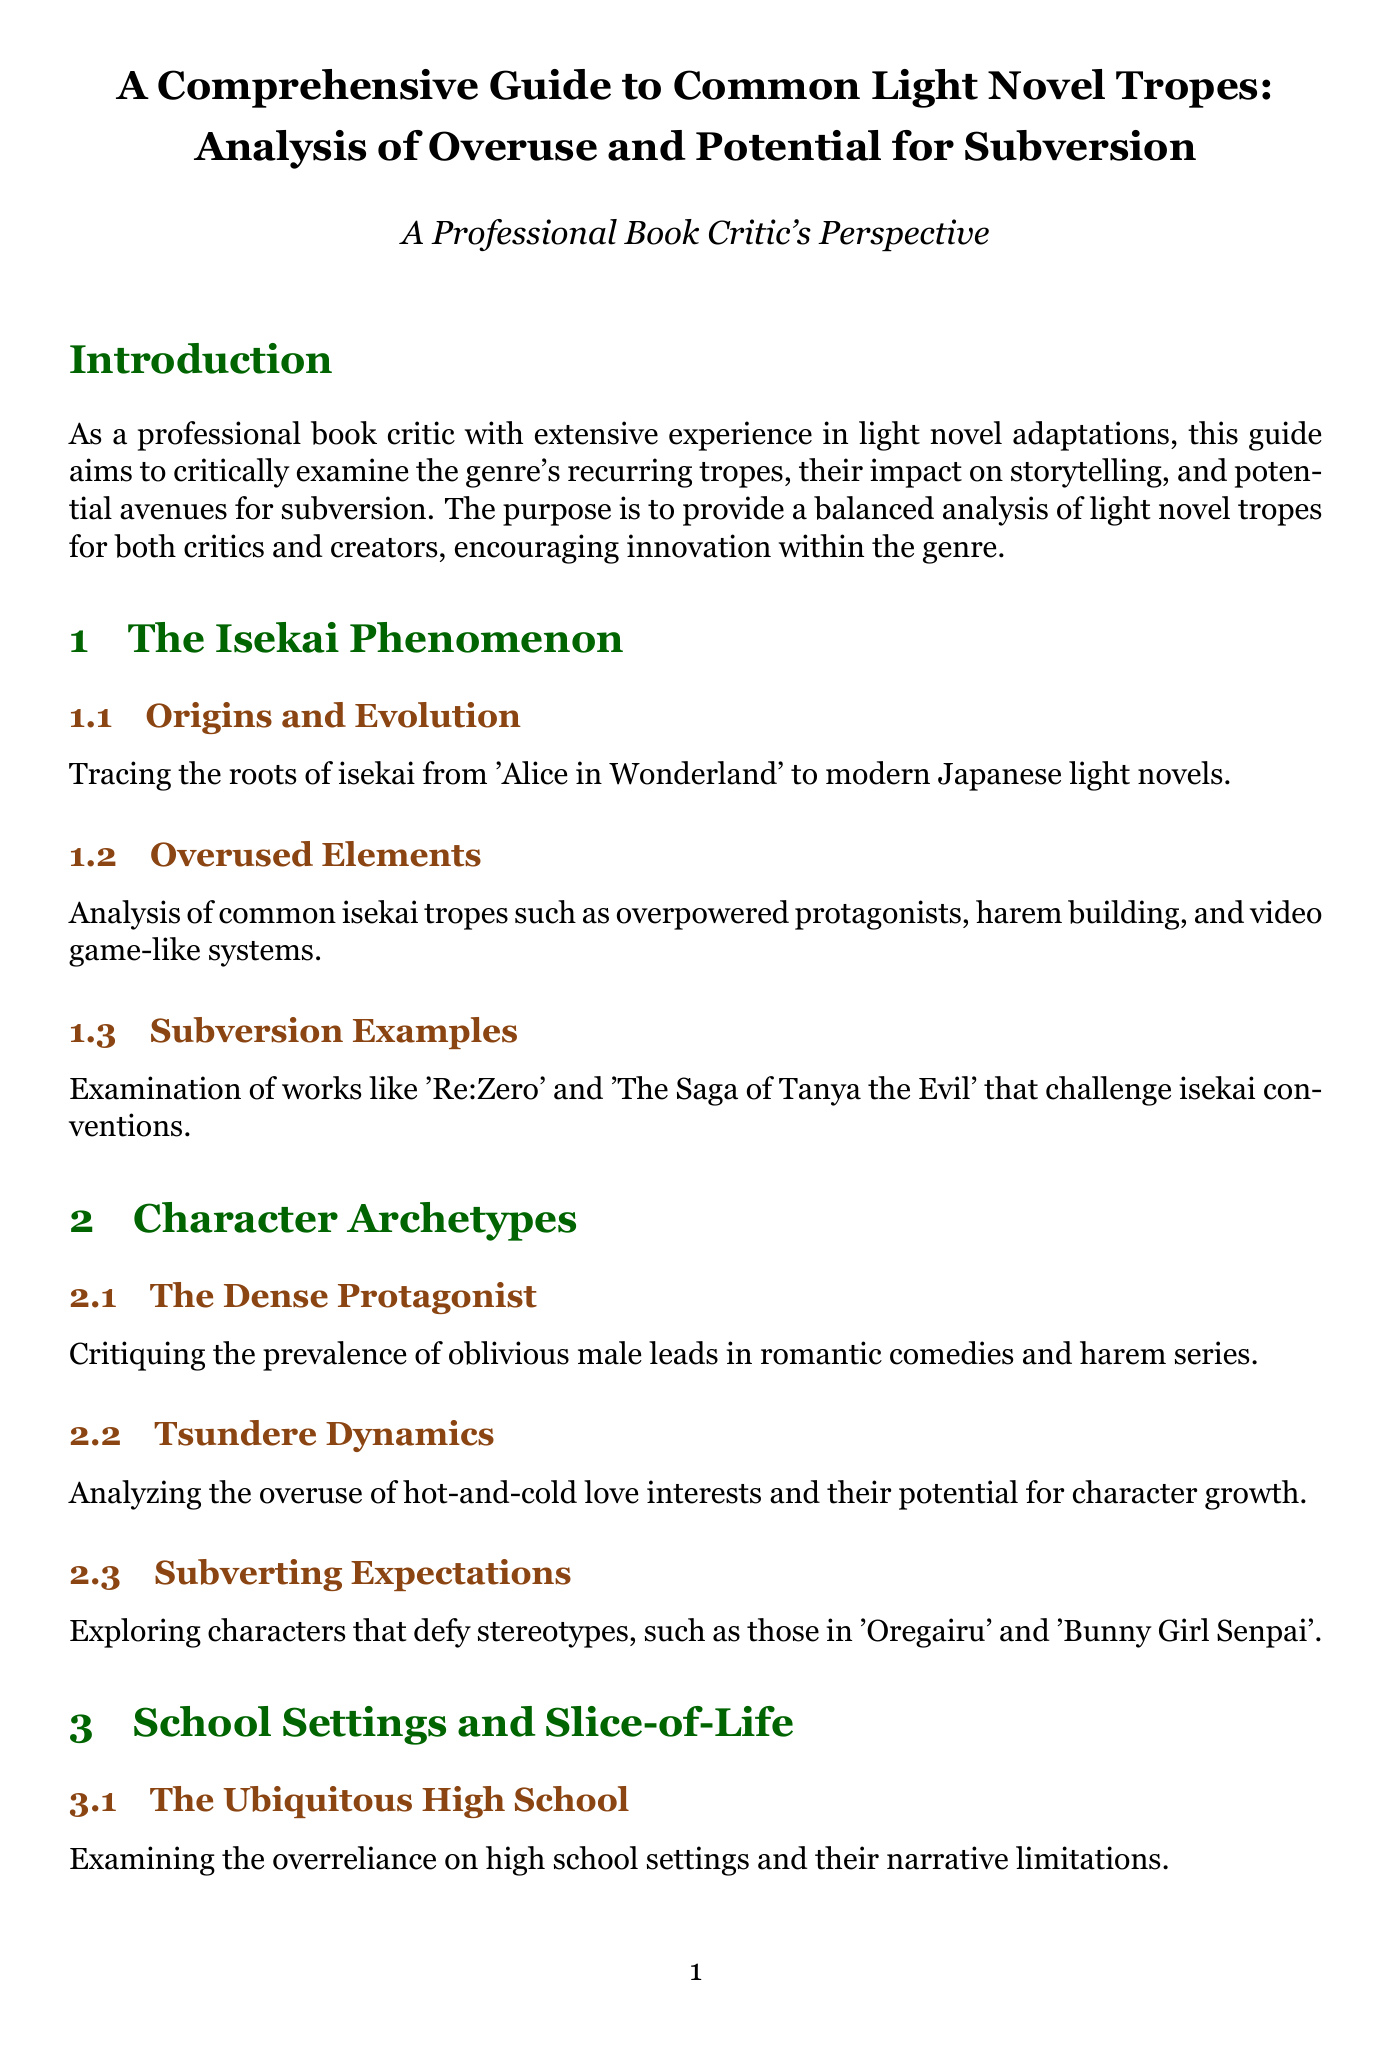What is the title of the guide? The title of the guide presents the main subject of the document, which is about examining light novel tropes.
Answer: A Comprehensive Guide to Common Light Novel Tropes: Analysis of Overuse and Potential for Subversion How many chapters are in the document? The total number of chapters is counted from the content structure provided in the document.
Answer: Five What is the focus of Chapter 2? Chapter 2 specifically addresses a common character type within light novels, as indicated by its title.
Answer: Character Archetypes Which light novel is mentioned as an example for subversion in isekai? The document lists specific works that challenge standard conventions in isekai stories.
Answer: Re:Zero What common trend is critiqued in "Power Fantasies and Wish Fulfillment"? This section discusses a specific type of protagonist prevalent in many narratives, indicating its issues.
Answer: The Gary Stu Protagonist What is one alternative approach to high school settings mentioned? The document offers examples of works that diverge from the typical school narrative, identifying an alternative setting.
Answer: Spice and Wolf Which series is noted for genre blending? The text cites certain works that successfully mix genres, highlighting their innovative qualities.
Answer: The Monogatari Series What does the conclusion encourage authors to do? The conclusion summarizes the guidance aim towards creators in terms of narrative creativity.
Answer: Take risks with unconventional narratives and character types 